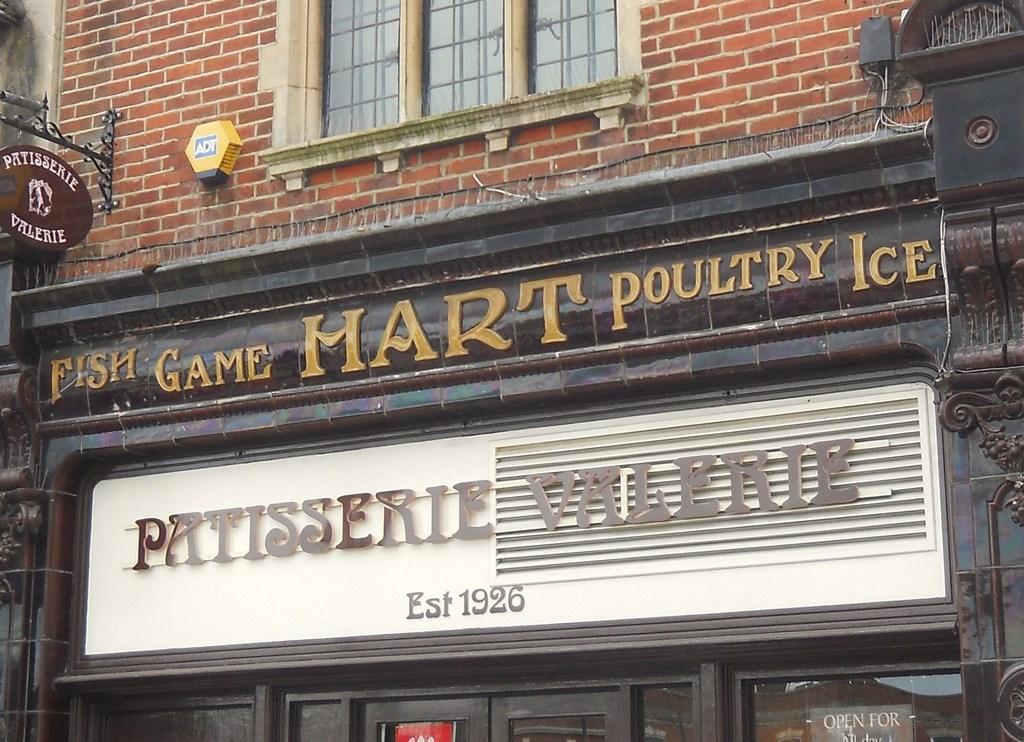In one or two sentences, can you explain what this image depicts? In the picture I can see a store which has something written on it and there is a glass window above it. 